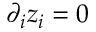Convert formula to latex. <formula><loc_0><loc_0><loc_500><loc_500>\partial _ { i } z _ { i } = 0</formula> 